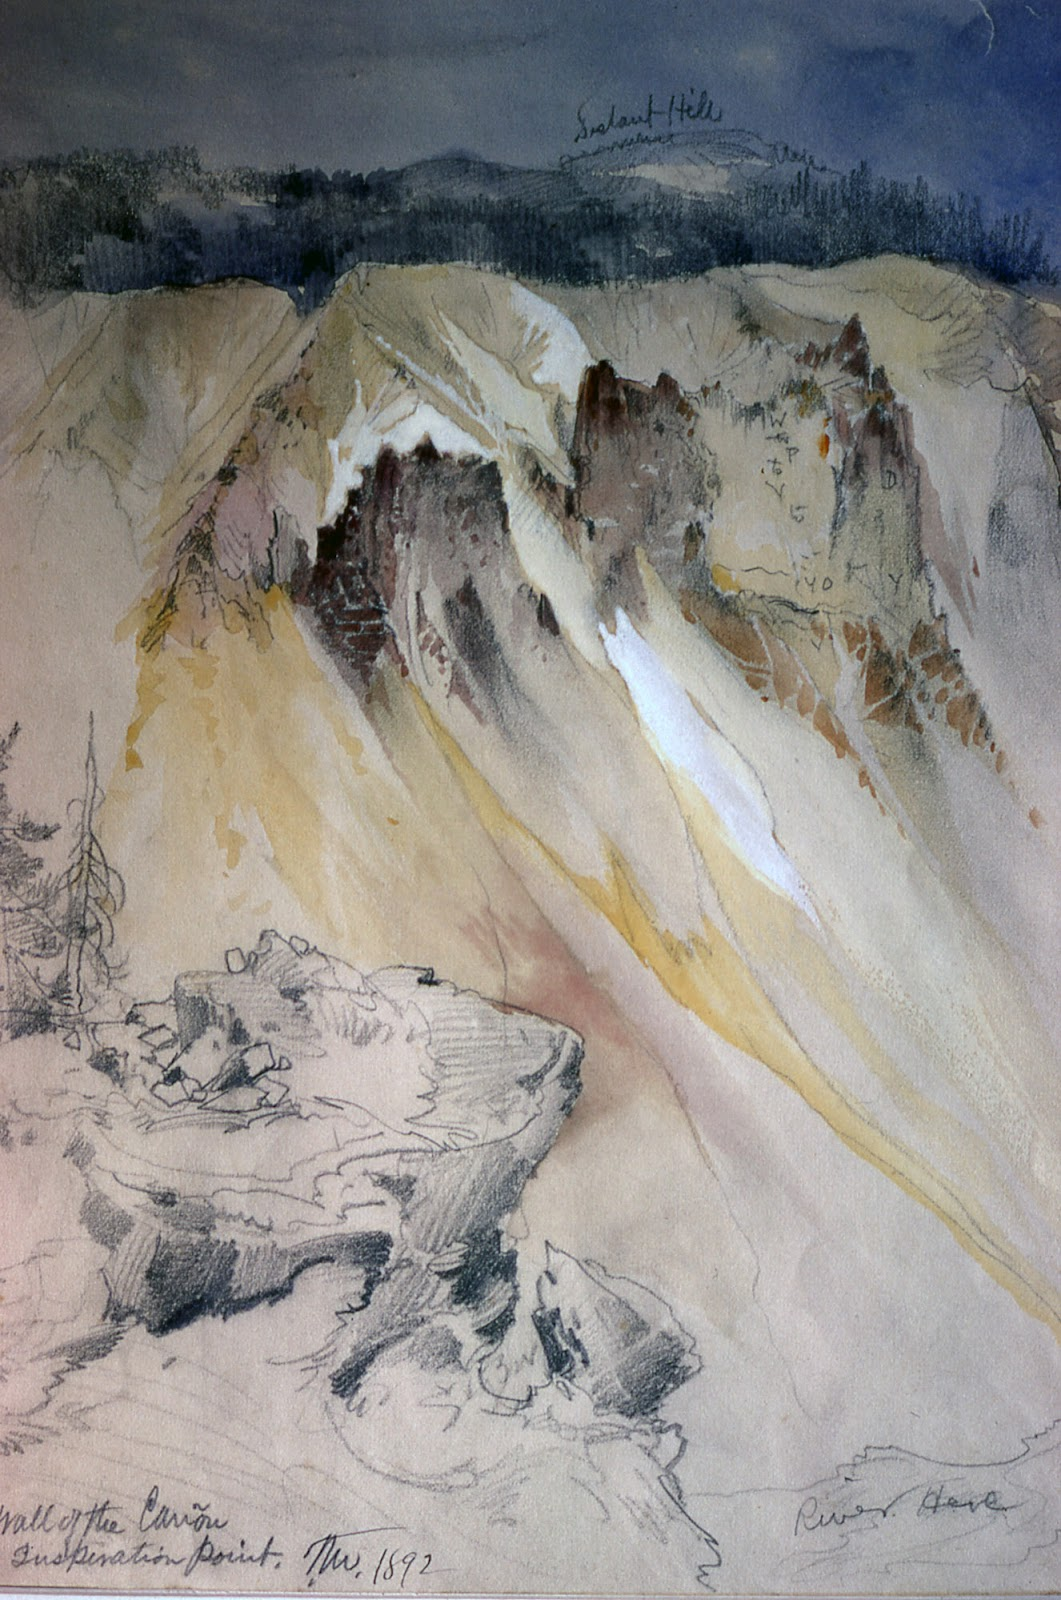Imagine this canyon comes alive. What do the mountains and rocks say? If the canyon could speak, its voice would be a deep, resonant echo, whispering the tales of millennia. The mountains would recall the primal forces that shaped them, the eruptions and erosions that carved their majestic forms. The rocks, ancient sentinels, would speak of their slow metamorphosis, the fossils they cradled and the roots they nourished. They would share stories of the eagles that soared above and the rushing rivers below, each element a thread in the vast tapestry of time. 